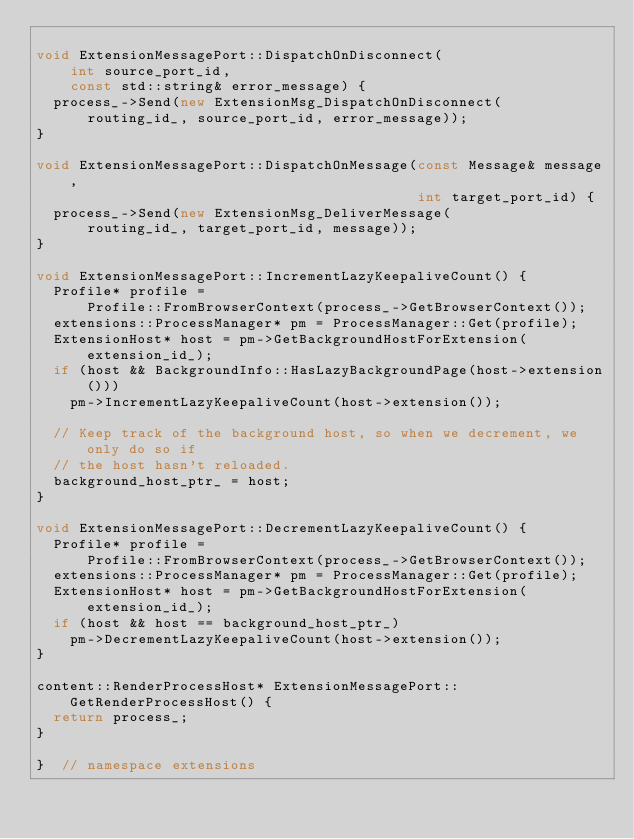Convert code to text. <code><loc_0><loc_0><loc_500><loc_500><_C++_>
void ExtensionMessagePort::DispatchOnDisconnect(
    int source_port_id,
    const std::string& error_message) {
  process_->Send(new ExtensionMsg_DispatchOnDisconnect(
      routing_id_, source_port_id, error_message));
}

void ExtensionMessagePort::DispatchOnMessage(const Message& message,
                                             int target_port_id) {
  process_->Send(new ExtensionMsg_DeliverMessage(
      routing_id_, target_port_id, message));
}

void ExtensionMessagePort::IncrementLazyKeepaliveCount() {
  Profile* profile =
      Profile::FromBrowserContext(process_->GetBrowserContext());
  extensions::ProcessManager* pm = ProcessManager::Get(profile);
  ExtensionHost* host = pm->GetBackgroundHostForExtension(extension_id_);
  if (host && BackgroundInfo::HasLazyBackgroundPage(host->extension()))
    pm->IncrementLazyKeepaliveCount(host->extension());

  // Keep track of the background host, so when we decrement, we only do so if
  // the host hasn't reloaded.
  background_host_ptr_ = host;
}

void ExtensionMessagePort::DecrementLazyKeepaliveCount() {
  Profile* profile =
      Profile::FromBrowserContext(process_->GetBrowserContext());
  extensions::ProcessManager* pm = ProcessManager::Get(profile);
  ExtensionHost* host = pm->GetBackgroundHostForExtension(extension_id_);
  if (host && host == background_host_ptr_)
    pm->DecrementLazyKeepaliveCount(host->extension());
}

content::RenderProcessHost* ExtensionMessagePort::GetRenderProcessHost() {
  return process_;
}

}  // namespace extensions
</code> 